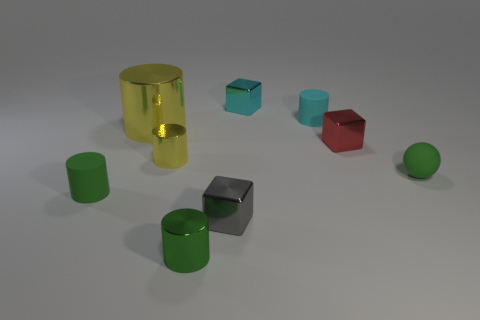The thing that is both behind the tiny red shiny cube and left of the small gray thing is made of what material? The object in question appears to be a cylinder with a metallic sheen, suggesting that it is made of a type of metal. Its reflective surface and color are indicative of metal materials commonly used in manufacturing various objects. 